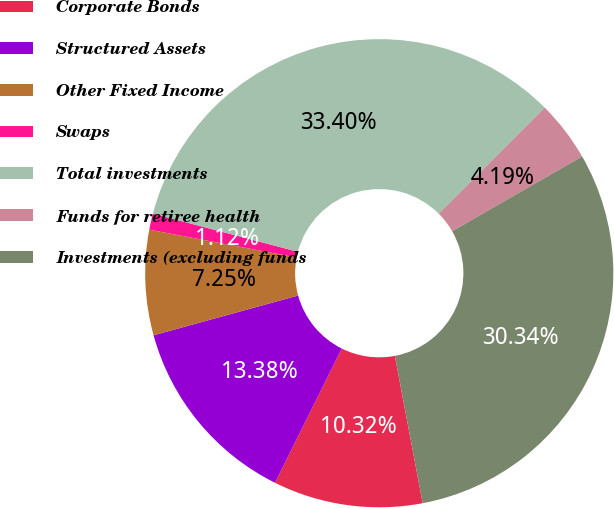Convert chart to OTSL. <chart><loc_0><loc_0><loc_500><loc_500><pie_chart><fcel>Corporate Bonds<fcel>Structured Assets<fcel>Other Fixed Income<fcel>Swaps<fcel>Total investments<fcel>Funds for retiree health<fcel>Investments (excluding funds<nl><fcel>10.32%<fcel>13.38%<fcel>7.25%<fcel>1.12%<fcel>33.4%<fcel>4.19%<fcel>30.34%<nl></chart> 